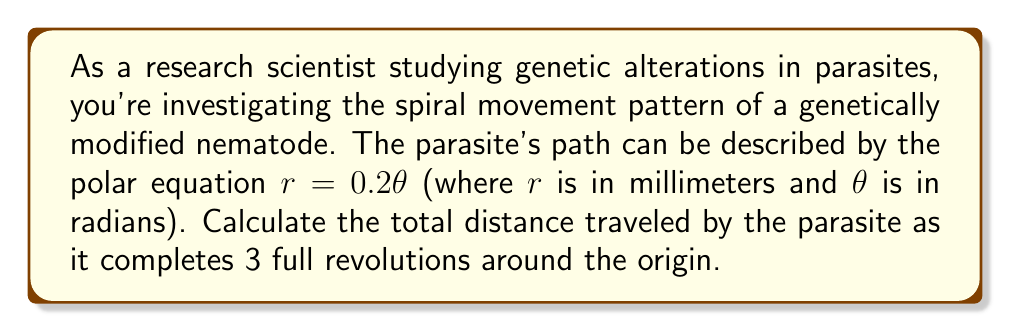Could you help me with this problem? To solve this problem, we need to follow these steps:

1) First, we need to understand that the spiral described by $r = 0.2\theta$ is an Archimedean spiral.

2) The arc length of a curve in polar coordinates from $\theta = a$ to $\theta = b$ is given by the formula:

   $$L = \int_a^b \sqrt{r^2 + \left(\frac{dr}{d\theta}\right)^2} d\theta$$

3) In our case, $r = 0.2\theta$, so $\frac{dr}{d\theta} = 0.2$

4) Substituting these into our arc length formula:

   $$L = \int_0^{6\pi} \sqrt{(0.2\theta)^2 + (0.2)^2} d\theta$$

5) Simplify inside the square root:

   $$L = \int_0^{6\pi} \sqrt{0.04\theta^2 + 0.04} d\theta$$

6) Factor out 0.04:

   $$L = 0.2 \int_0^{6\pi} \sqrt{\theta^2 + 1} d\theta$$

7) This integral doesn't have an elementary antiderivative. We need to use the following result:

   $$\int \sqrt{\theta^2 + 1} d\theta = \frac{1}{2}\left(\theta\sqrt{\theta^2 + 1} + \ln|\theta + \sqrt{\theta^2 + 1}|\right) + C$$

8) Applying the limits:

   $$L = 0.2 \left[ \frac{1}{2}\left(\theta\sqrt{\theta^2 + 1} + \ln|\theta + \sqrt{\theta^2 + 1}|\right) \right]_0^{6\pi}$$

9) Evaluate:

   $$L = 0.1 \left[ 6\pi\sqrt{36\pi^2 + 1} + \ln|6\pi + \sqrt{36\pi^2 + 1}| - (0 + \ln 1) \right]$$

10) Simplify and calculate (using a calculator for the numerical values):

    $$L \approx 0.1 (678.58 + 4.49) \approx 68.31 \text{ mm}$$
Answer: The total distance traveled by the parasite after 3 full revolutions is approximately 68.31 mm. 